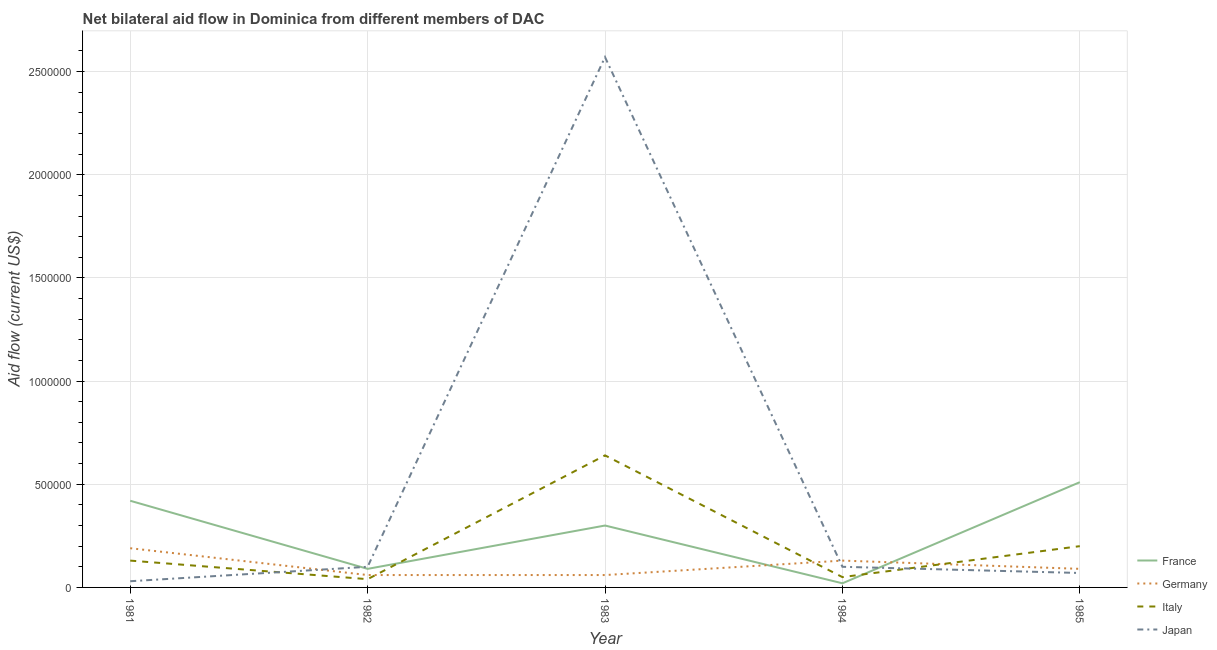How many different coloured lines are there?
Your answer should be compact. 4. Is the number of lines equal to the number of legend labels?
Ensure brevity in your answer.  Yes. What is the amount of aid given by japan in 1982?
Keep it short and to the point. 1.00e+05. Across all years, what is the maximum amount of aid given by france?
Your response must be concise. 5.10e+05. Across all years, what is the minimum amount of aid given by italy?
Provide a short and direct response. 4.00e+04. What is the total amount of aid given by france in the graph?
Provide a succinct answer. 1.34e+06. What is the difference between the amount of aid given by japan in 1983 and that in 1984?
Your answer should be compact. 2.47e+06. What is the difference between the amount of aid given by japan in 1982 and the amount of aid given by france in 1985?
Ensure brevity in your answer.  -4.10e+05. What is the average amount of aid given by japan per year?
Provide a succinct answer. 5.74e+05. In the year 1982, what is the difference between the amount of aid given by japan and amount of aid given by germany?
Offer a very short reply. 4.00e+04. In how many years, is the amount of aid given by france greater than 1600000 US$?
Make the answer very short. 0. What is the ratio of the amount of aid given by japan in 1981 to that in 1985?
Ensure brevity in your answer.  0.43. What is the difference between the highest and the second highest amount of aid given by italy?
Give a very brief answer. 4.40e+05. What is the difference between the highest and the lowest amount of aid given by germany?
Your answer should be very brief. 1.30e+05. In how many years, is the amount of aid given by france greater than the average amount of aid given by france taken over all years?
Keep it short and to the point. 3. Is the sum of the amount of aid given by italy in 1984 and 1985 greater than the maximum amount of aid given by france across all years?
Your answer should be compact. No. Is it the case that in every year, the sum of the amount of aid given by france and amount of aid given by germany is greater than the amount of aid given by italy?
Keep it short and to the point. No. Does the amount of aid given by japan monotonically increase over the years?
Your answer should be compact. No. Is the amount of aid given by italy strictly greater than the amount of aid given by germany over the years?
Make the answer very short. No. Is the amount of aid given by japan strictly less than the amount of aid given by italy over the years?
Offer a very short reply. No. What is the difference between two consecutive major ticks on the Y-axis?
Ensure brevity in your answer.  5.00e+05. Where does the legend appear in the graph?
Your answer should be compact. Bottom right. What is the title of the graph?
Offer a very short reply. Net bilateral aid flow in Dominica from different members of DAC. Does "Quality of logistic services" appear as one of the legend labels in the graph?
Your answer should be compact. No. What is the label or title of the X-axis?
Your response must be concise. Year. What is the label or title of the Y-axis?
Provide a succinct answer. Aid flow (current US$). What is the Aid flow (current US$) in France in 1981?
Provide a succinct answer. 4.20e+05. What is the Aid flow (current US$) of Italy in 1981?
Provide a short and direct response. 1.30e+05. What is the Aid flow (current US$) in France in 1982?
Your response must be concise. 9.00e+04. What is the Aid flow (current US$) in Germany in 1982?
Ensure brevity in your answer.  6.00e+04. What is the Aid flow (current US$) of Japan in 1982?
Ensure brevity in your answer.  1.00e+05. What is the Aid flow (current US$) in Italy in 1983?
Offer a terse response. 6.40e+05. What is the Aid flow (current US$) of Japan in 1983?
Your response must be concise. 2.57e+06. What is the Aid flow (current US$) of France in 1984?
Offer a very short reply. 2.00e+04. What is the Aid flow (current US$) of Italy in 1984?
Make the answer very short. 5.00e+04. What is the Aid flow (current US$) of Japan in 1984?
Your answer should be compact. 1.00e+05. What is the Aid flow (current US$) in France in 1985?
Your response must be concise. 5.10e+05. What is the Aid flow (current US$) in Germany in 1985?
Provide a short and direct response. 9.00e+04. What is the Aid flow (current US$) in Japan in 1985?
Your answer should be very brief. 7.00e+04. Across all years, what is the maximum Aid flow (current US$) in France?
Your response must be concise. 5.10e+05. Across all years, what is the maximum Aid flow (current US$) in Germany?
Your response must be concise. 1.90e+05. Across all years, what is the maximum Aid flow (current US$) in Italy?
Keep it short and to the point. 6.40e+05. Across all years, what is the maximum Aid flow (current US$) of Japan?
Give a very brief answer. 2.57e+06. Across all years, what is the minimum Aid flow (current US$) of Italy?
Ensure brevity in your answer.  4.00e+04. What is the total Aid flow (current US$) in France in the graph?
Keep it short and to the point. 1.34e+06. What is the total Aid flow (current US$) of Germany in the graph?
Provide a succinct answer. 5.30e+05. What is the total Aid flow (current US$) of Italy in the graph?
Your response must be concise. 1.06e+06. What is the total Aid flow (current US$) of Japan in the graph?
Ensure brevity in your answer.  2.87e+06. What is the difference between the Aid flow (current US$) of France in 1981 and that in 1982?
Offer a terse response. 3.30e+05. What is the difference between the Aid flow (current US$) in Germany in 1981 and that in 1982?
Make the answer very short. 1.30e+05. What is the difference between the Aid flow (current US$) of France in 1981 and that in 1983?
Your answer should be very brief. 1.20e+05. What is the difference between the Aid flow (current US$) of Italy in 1981 and that in 1983?
Your answer should be very brief. -5.10e+05. What is the difference between the Aid flow (current US$) in Japan in 1981 and that in 1983?
Keep it short and to the point. -2.54e+06. What is the difference between the Aid flow (current US$) of Italy in 1981 and that in 1984?
Your answer should be compact. 8.00e+04. What is the difference between the Aid flow (current US$) of France in 1981 and that in 1985?
Provide a succinct answer. -9.00e+04. What is the difference between the Aid flow (current US$) of Italy in 1981 and that in 1985?
Offer a terse response. -7.00e+04. What is the difference between the Aid flow (current US$) of Germany in 1982 and that in 1983?
Offer a very short reply. 0. What is the difference between the Aid flow (current US$) in Italy in 1982 and that in 1983?
Provide a short and direct response. -6.00e+05. What is the difference between the Aid flow (current US$) in Japan in 1982 and that in 1983?
Offer a terse response. -2.47e+06. What is the difference between the Aid flow (current US$) of France in 1982 and that in 1985?
Your answer should be very brief. -4.20e+05. What is the difference between the Aid flow (current US$) of Germany in 1982 and that in 1985?
Your answer should be compact. -3.00e+04. What is the difference between the Aid flow (current US$) in Japan in 1982 and that in 1985?
Your answer should be compact. 3.00e+04. What is the difference between the Aid flow (current US$) of France in 1983 and that in 1984?
Your answer should be compact. 2.80e+05. What is the difference between the Aid flow (current US$) of Germany in 1983 and that in 1984?
Provide a short and direct response. -7.00e+04. What is the difference between the Aid flow (current US$) of Italy in 1983 and that in 1984?
Your answer should be compact. 5.90e+05. What is the difference between the Aid flow (current US$) of Japan in 1983 and that in 1984?
Offer a terse response. 2.47e+06. What is the difference between the Aid flow (current US$) in Japan in 1983 and that in 1985?
Offer a very short reply. 2.50e+06. What is the difference between the Aid flow (current US$) of France in 1984 and that in 1985?
Make the answer very short. -4.90e+05. What is the difference between the Aid flow (current US$) in Germany in 1984 and that in 1985?
Offer a very short reply. 4.00e+04. What is the difference between the Aid flow (current US$) in France in 1981 and the Aid flow (current US$) in Japan in 1982?
Your answer should be compact. 3.20e+05. What is the difference between the Aid flow (current US$) of Germany in 1981 and the Aid flow (current US$) of Italy in 1982?
Give a very brief answer. 1.50e+05. What is the difference between the Aid flow (current US$) of Germany in 1981 and the Aid flow (current US$) of Japan in 1982?
Your answer should be very brief. 9.00e+04. What is the difference between the Aid flow (current US$) in France in 1981 and the Aid flow (current US$) in Germany in 1983?
Make the answer very short. 3.60e+05. What is the difference between the Aid flow (current US$) in France in 1981 and the Aid flow (current US$) in Italy in 1983?
Make the answer very short. -2.20e+05. What is the difference between the Aid flow (current US$) of France in 1981 and the Aid flow (current US$) of Japan in 1983?
Keep it short and to the point. -2.15e+06. What is the difference between the Aid flow (current US$) of Germany in 1981 and the Aid flow (current US$) of Italy in 1983?
Offer a very short reply. -4.50e+05. What is the difference between the Aid flow (current US$) of Germany in 1981 and the Aid flow (current US$) of Japan in 1983?
Provide a succinct answer. -2.38e+06. What is the difference between the Aid flow (current US$) of Italy in 1981 and the Aid flow (current US$) of Japan in 1983?
Give a very brief answer. -2.44e+06. What is the difference between the Aid flow (current US$) in Germany in 1981 and the Aid flow (current US$) in Italy in 1984?
Ensure brevity in your answer.  1.40e+05. What is the difference between the Aid flow (current US$) in Germany in 1981 and the Aid flow (current US$) in Japan in 1984?
Your answer should be very brief. 9.00e+04. What is the difference between the Aid flow (current US$) of Italy in 1981 and the Aid flow (current US$) of Japan in 1984?
Your answer should be very brief. 3.00e+04. What is the difference between the Aid flow (current US$) of France in 1981 and the Aid flow (current US$) of Germany in 1985?
Your answer should be very brief. 3.30e+05. What is the difference between the Aid flow (current US$) of Germany in 1981 and the Aid flow (current US$) of Japan in 1985?
Give a very brief answer. 1.20e+05. What is the difference between the Aid flow (current US$) of Italy in 1981 and the Aid flow (current US$) of Japan in 1985?
Provide a succinct answer. 6.00e+04. What is the difference between the Aid flow (current US$) of France in 1982 and the Aid flow (current US$) of Germany in 1983?
Make the answer very short. 3.00e+04. What is the difference between the Aid flow (current US$) in France in 1982 and the Aid flow (current US$) in Italy in 1983?
Provide a succinct answer. -5.50e+05. What is the difference between the Aid flow (current US$) of France in 1982 and the Aid flow (current US$) of Japan in 1983?
Your answer should be compact. -2.48e+06. What is the difference between the Aid flow (current US$) in Germany in 1982 and the Aid flow (current US$) in Italy in 1983?
Ensure brevity in your answer.  -5.80e+05. What is the difference between the Aid flow (current US$) of Germany in 1982 and the Aid flow (current US$) of Japan in 1983?
Your answer should be compact. -2.51e+06. What is the difference between the Aid flow (current US$) of Italy in 1982 and the Aid flow (current US$) of Japan in 1983?
Provide a succinct answer. -2.53e+06. What is the difference between the Aid flow (current US$) in France in 1982 and the Aid flow (current US$) in Italy in 1984?
Your answer should be very brief. 4.00e+04. What is the difference between the Aid flow (current US$) of France in 1982 and the Aid flow (current US$) of Japan in 1984?
Offer a terse response. -10000. What is the difference between the Aid flow (current US$) of Germany in 1982 and the Aid flow (current US$) of Japan in 1984?
Offer a very short reply. -4.00e+04. What is the difference between the Aid flow (current US$) of France in 1982 and the Aid flow (current US$) of Italy in 1985?
Make the answer very short. -1.10e+05. What is the difference between the Aid flow (current US$) in France in 1982 and the Aid flow (current US$) in Japan in 1985?
Your answer should be compact. 2.00e+04. What is the difference between the Aid flow (current US$) in Germany in 1982 and the Aid flow (current US$) in Japan in 1985?
Provide a short and direct response. -10000. What is the difference between the Aid flow (current US$) in Italy in 1982 and the Aid flow (current US$) in Japan in 1985?
Ensure brevity in your answer.  -3.00e+04. What is the difference between the Aid flow (current US$) in France in 1983 and the Aid flow (current US$) in Germany in 1984?
Ensure brevity in your answer.  1.70e+05. What is the difference between the Aid flow (current US$) of France in 1983 and the Aid flow (current US$) of Italy in 1984?
Make the answer very short. 2.50e+05. What is the difference between the Aid flow (current US$) of Germany in 1983 and the Aid flow (current US$) of Italy in 1984?
Keep it short and to the point. 10000. What is the difference between the Aid flow (current US$) in Germany in 1983 and the Aid flow (current US$) in Japan in 1984?
Offer a very short reply. -4.00e+04. What is the difference between the Aid flow (current US$) in Italy in 1983 and the Aid flow (current US$) in Japan in 1984?
Your answer should be compact. 5.40e+05. What is the difference between the Aid flow (current US$) in France in 1983 and the Aid flow (current US$) in Germany in 1985?
Provide a short and direct response. 2.10e+05. What is the difference between the Aid flow (current US$) in Germany in 1983 and the Aid flow (current US$) in Italy in 1985?
Your response must be concise. -1.40e+05. What is the difference between the Aid flow (current US$) of Germany in 1983 and the Aid flow (current US$) of Japan in 1985?
Keep it short and to the point. -10000. What is the difference between the Aid flow (current US$) of Italy in 1983 and the Aid flow (current US$) of Japan in 1985?
Offer a very short reply. 5.70e+05. What is the difference between the Aid flow (current US$) of France in 1984 and the Aid flow (current US$) of Japan in 1985?
Your answer should be compact. -5.00e+04. What is the difference between the Aid flow (current US$) in Italy in 1984 and the Aid flow (current US$) in Japan in 1985?
Ensure brevity in your answer.  -2.00e+04. What is the average Aid flow (current US$) in France per year?
Keep it short and to the point. 2.68e+05. What is the average Aid flow (current US$) in Germany per year?
Offer a terse response. 1.06e+05. What is the average Aid flow (current US$) in Italy per year?
Provide a short and direct response. 2.12e+05. What is the average Aid flow (current US$) in Japan per year?
Ensure brevity in your answer.  5.74e+05. In the year 1981, what is the difference between the Aid flow (current US$) in France and Aid flow (current US$) in Germany?
Provide a short and direct response. 2.30e+05. In the year 1981, what is the difference between the Aid flow (current US$) of France and Aid flow (current US$) of Japan?
Keep it short and to the point. 3.90e+05. In the year 1981, what is the difference between the Aid flow (current US$) in Italy and Aid flow (current US$) in Japan?
Keep it short and to the point. 1.00e+05. In the year 1982, what is the difference between the Aid flow (current US$) in France and Aid flow (current US$) in Italy?
Provide a short and direct response. 5.00e+04. In the year 1982, what is the difference between the Aid flow (current US$) in France and Aid flow (current US$) in Japan?
Your answer should be very brief. -10000. In the year 1982, what is the difference between the Aid flow (current US$) of Italy and Aid flow (current US$) of Japan?
Your answer should be very brief. -6.00e+04. In the year 1983, what is the difference between the Aid flow (current US$) in France and Aid flow (current US$) in Japan?
Provide a succinct answer. -2.27e+06. In the year 1983, what is the difference between the Aid flow (current US$) in Germany and Aid flow (current US$) in Italy?
Your answer should be very brief. -5.80e+05. In the year 1983, what is the difference between the Aid flow (current US$) in Germany and Aid flow (current US$) in Japan?
Your response must be concise. -2.51e+06. In the year 1983, what is the difference between the Aid flow (current US$) of Italy and Aid flow (current US$) of Japan?
Keep it short and to the point. -1.93e+06. In the year 1984, what is the difference between the Aid flow (current US$) in France and Aid flow (current US$) in Germany?
Ensure brevity in your answer.  -1.10e+05. In the year 1984, what is the difference between the Aid flow (current US$) in France and Aid flow (current US$) in Japan?
Ensure brevity in your answer.  -8.00e+04. In the year 1984, what is the difference between the Aid flow (current US$) of Germany and Aid flow (current US$) of Italy?
Give a very brief answer. 8.00e+04. In the year 1984, what is the difference between the Aid flow (current US$) of Italy and Aid flow (current US$) of Japan?
Ensure brevity in your answer.  -5.00e+04. In the year 1985, what is the difference between the Aid flow (current US$) in France and Aid flow (current US$) in Germany?
Your answer should be very brief. 4.20e+05. In the year 1985, what is the difference between the Aid flow (current US$) of France and Aid flow (current US$) of Italy?
Provide a succinct answer. 3.10e+05. In the year 1985, what is the difference between the Aid flow (current US$) of Germany and Aid flow (current US$) of Japan?
Offer a very short reply. 2.00e+04. What is the ratio of the Aid flow (current US$) of France in 1981 to that in 1982?
Offer a terse response. 4.67. What is the ratio of the Aid flow (current US$) of Germany in 1981 to that in 1982?
Your response must be concise. 3.17. What is the ratio of the Aid flow (current US$) in Italy in 1981 to that in 1982?
Your answer should be compact. 3.25. What is the ratio of the Aid flow (current US$) of Japan in 1981 to that in 1982?
Ensure brevity in your answer.  0.3. What is the ratio of the Aid flow (current US$) in France in 1981 to that in 1983?
Make the answer very short. 1.4. What is the ratio of the Aid flow (current US$) of Germany in 1981 to that in 1983?
Offer a very short reply. 3.17. What is the ratio of the Aid flow (current US$) in Italy in 1981 to that in 1983?
Offer a terse response. 0.2. What is the ratio of the Aid flow (current US$) of Japan in 1981 to that in 1983?
Ensure brevity in your answer.  0.01. What is the ratio of the Aid flow (current US$) of Germany in 1981 to that in 1984?
Provide a short and direct response. 1.46. What is the ratio of the Aid flow (current US$) in Italy in 1981 to that in 1984?
Provide a short and direct response. 2.6. What is the ratio of the Aid flow (current US$) in Japan in 1981 to that in 1984?
Your answer should be compact. 0.3. What is the ratio of the Aid flow (current US$) of France in 1981 to that in 1985?
Your answer should be compact. 0.82. What is the ratio of the Aid flow (current US$) of Germany in 1981 to that in 1985?
Provide a succinct answer. 2.11. What is the ratio of the Aid flow (current US$) of Italy in 1981 to that in 1985?
Provide a short and direct response. 0.65. What is the ratio of the Aid flow (current US$) in Japan in 1981 to that in 1985?
Provide a short and direct response. 0.43. What is the ratio of the Aid flow (current US$) of Germany in 1982 to that in 1983?
Offer a terse response. 1. What is the ratio of the Aid flow (current US$) in Italy in 1982 to that in 1983?
Keep it short and to the point. 0.06. What is the ratio of the Aid flow (current US$) in Japan in 1982 to that in 1983?
Provide a short and direct response. 0.04. What is the ratio of the Aid flow (current US$) of Germany in 1982 to that in 1984?
Provide a short and direct response. 0.46. What is the ratio of the Aid flow (current US$) in Italy in 1982 to that in 1984?
Your answer should be very brief. 0.8. What is the ratio of the Aid flow (current US$) in France in 1982 to that in 1985?
Give a very brief answer. 0.18. What is the ratio of the Aid flow (current US$) of Germany in 1982 to that in 1985?
Keep it short and to the point. 0.67. What is the ratio of the Aid flow (current US$) in Japan in 1982 to that in 1985?
Your answer should be very brief. 1.43. What is the ratio of the Aid flow (current US$) of France in 1983 to that in 1984?
Keep it short and to the point. 15. What is the ratio of the Aid flow (current US$) in Germany in 1983 to that in 1984?
Offer a terse response. 0.46. What is the ratio of the Aid flow (current US$) of Japan in 1983 to that in 1984?
Your answer should be compact. 25.7. What is the ratio of the Aid flow (current US$) of France in 1983 to that in 1985?
Offer a terse response. 0.59. What is the ratio of the Aid flow (current US$) of Italy in 1983 to that in 1985?
Ensure brevity in your answer.  3.2. What is the ratio of the Aid flow (current US$) of Japan in 1983 to that in 1985?
Provide a succinct answer. 36.71. What is the ratio of the Aid flow (current US$) in France in 1984 to that in 1985?
Offer a very short reply. 0.04. What is the ratio of the Aid flow (current US$) of Germany in 1984 to that in 1985?
Your answer should be very brief. 1.44. What is the ratio of the Aid flow (current US$) in Japan in 1984 to that in 1985?
Provide a short and direct response. 1.43. What is the difference between the highest and the second highest Aid flow (current US$) in Germany?
Offer a terse response. 6.00e+04. What is the difference between the highest and the second highest Aid flow (current US$) of Japan?
Offer a terse response. 2.47e+06. What is the difference between the highest and the lowest Aid flow (current US$) of Italy?
Ensure brevity in your answer.  6.00e+05. What is the difference between the highest and the lowest Aid flow (current US$) in Japan?
Keep it short and to the point. 2.54e+06. 